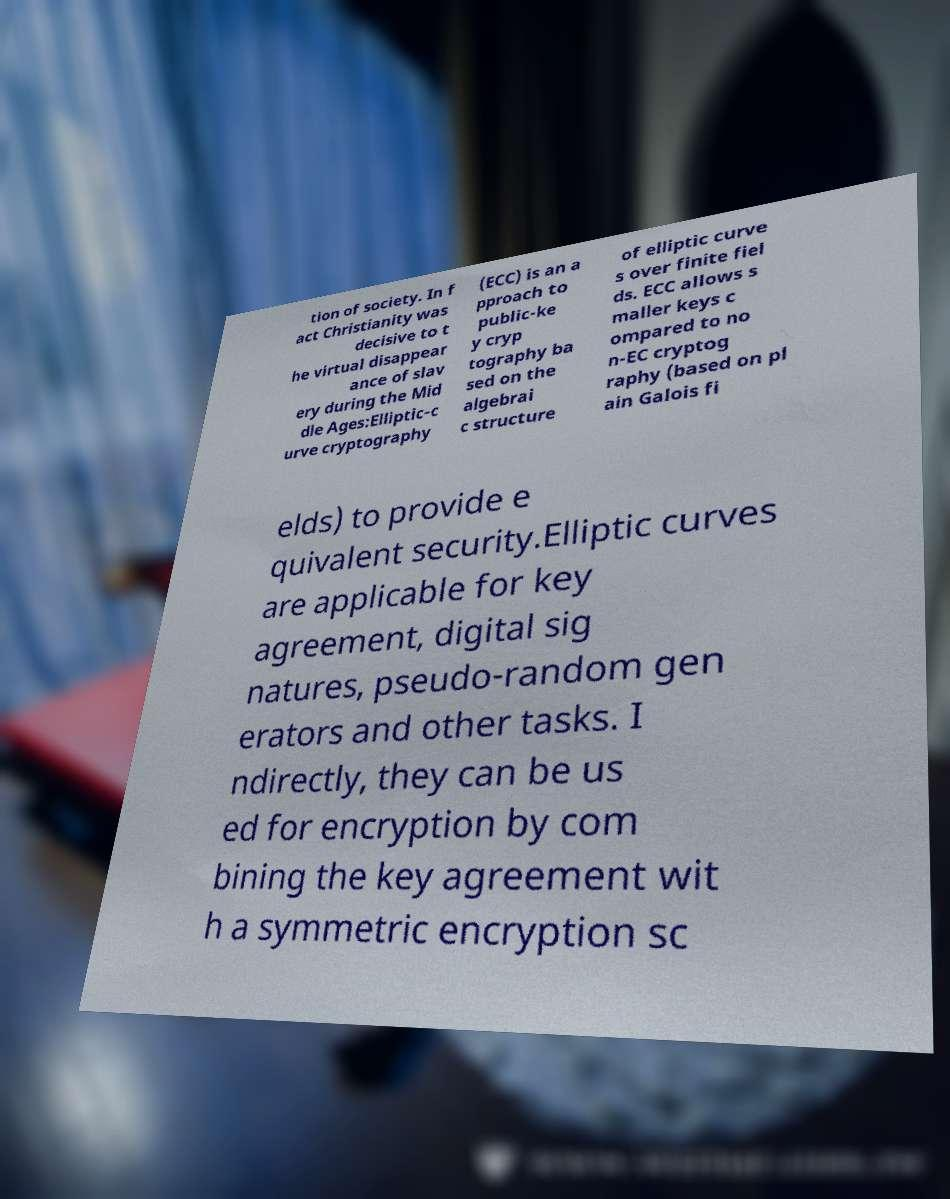Please read and relay the text visible in this image. What does it say? tion of society. In f act Christianity was decisive to t he virtual disappear ance of slav ery during the Mid dle Ages:Elliptic-c urve cryptography (ECC) is an a pproach to public-ke y cryp tography ba sed on the algebrai c structure of elliptic curve s over finite fiel ds. ECC allows s maller keys c ompared to no n-EC cryptog raphy (based on pl ain Galois fi elds) to provide e quivalent security.Elliptic curves are applicable for key agreement, digital sig natures, pseudo-random gen erators and other tasks. I ndirectly, they can be us ed for encryption by com bining the key agreement wit h a symmetric encryption sc 